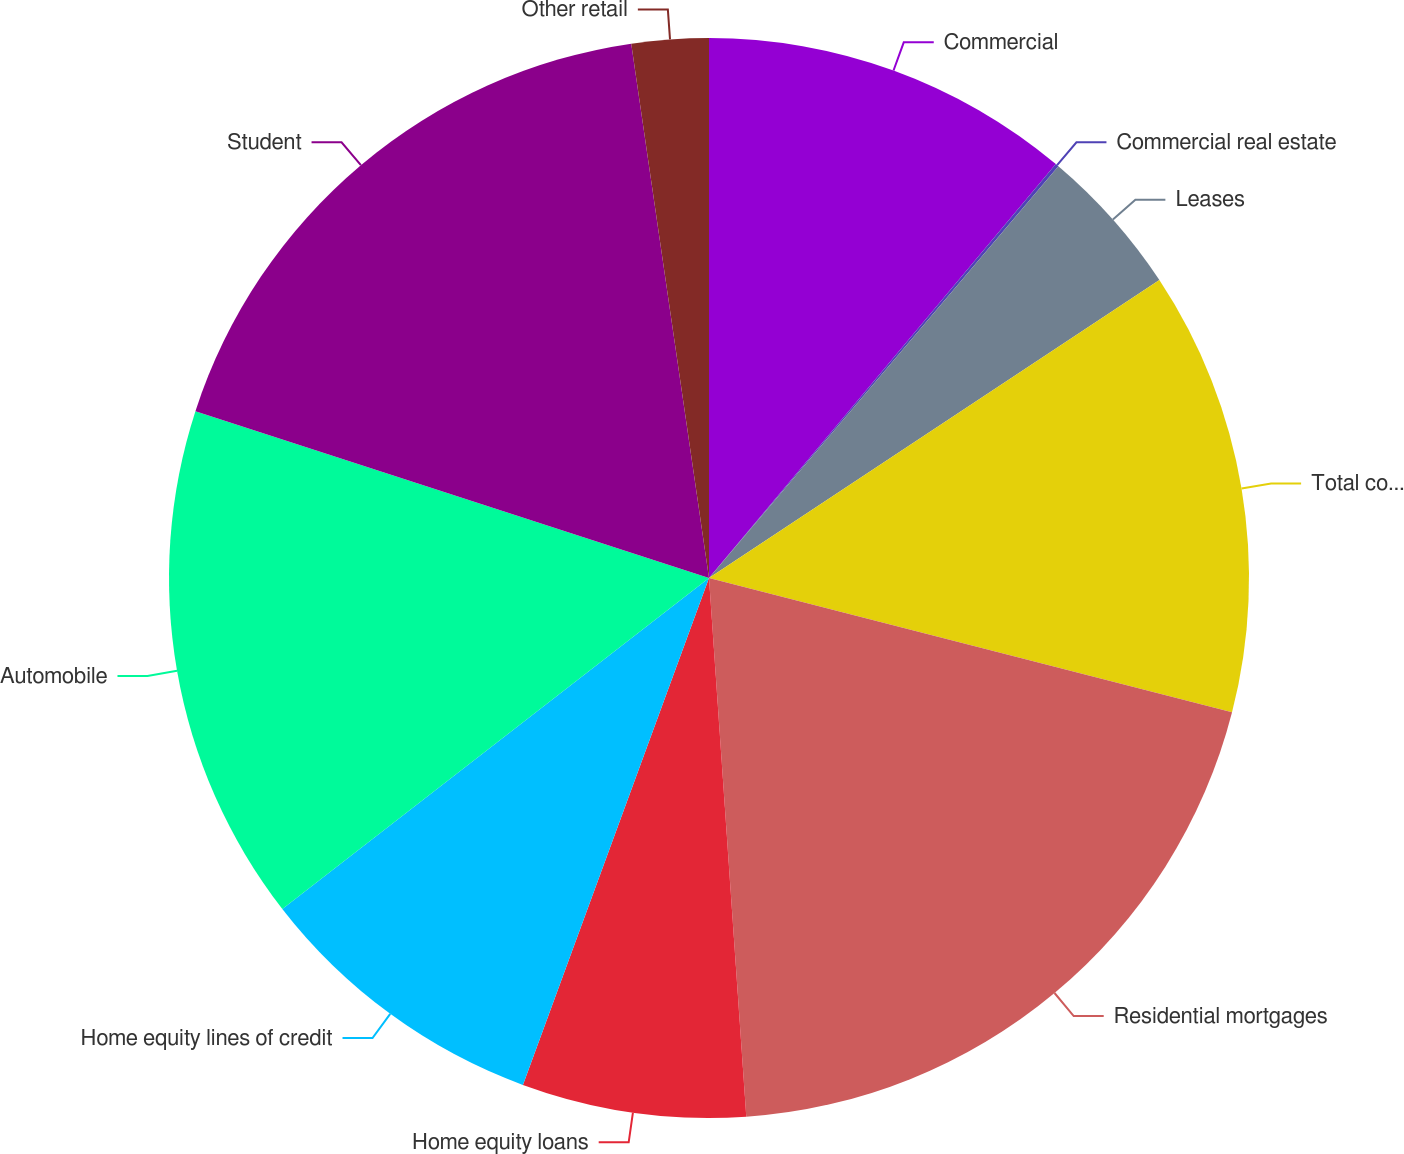<chart> <loc_0><loc_0><loc_500><loc_500><pie_chart><fcel>Commercial<fcel>Commercial real estate<fcel>Leases<fcel>Total commercial<fcel>Residential mortgages<fcel>Home equity loans<fcel>Home equity lines of credit<fcel>Automobile<fcel>Student<fcel>Other retail<nl><fcel>11.1%<fcel>0.1%<fcel>4.5%<fcel>13.3%<fcel>19.9%<fcel>6.7%<fcel>8.9%<fcel>15.5%<fcel>17.7%<fcel>2.3%<nl></chart> 